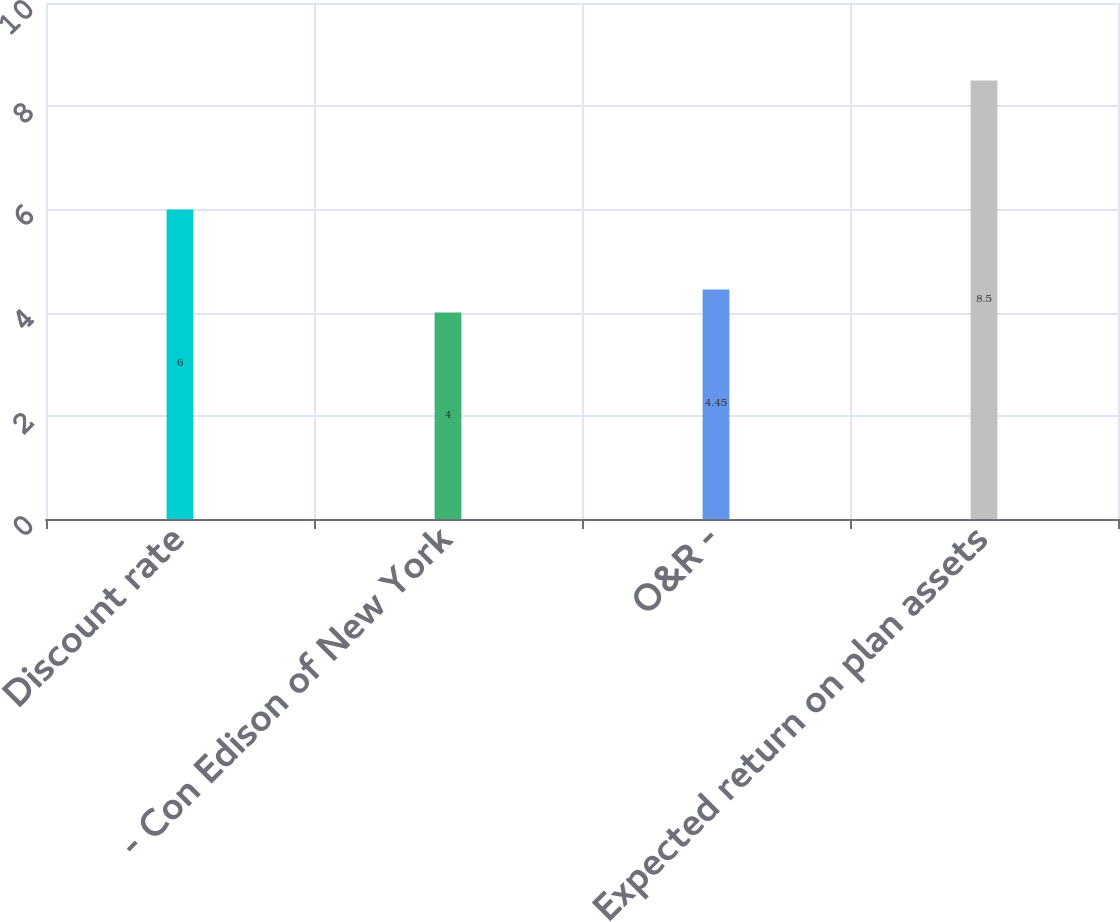Convert chart to OTSL. <chart><loc_0><loc_0><loc_500><loc_500><bar_chart><fcel>Discount rate<fcel>- Con Edison of New York<fcel>O&R -<fcel>Expected return on plan assets<nl><fcel>6<fcel>4<fcel>4.45<fcel>8.5<nl></chart> 